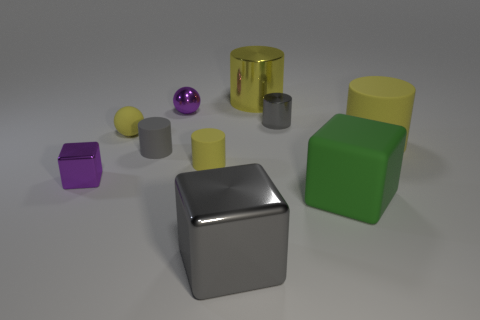If I were teaching a child about shapes, how could I use this image? This image is an excellent resource for teaching shapes. You can point out the sphere, cube, and cylinder, and explain how a cube has six equal square faces, a sphere has a round, three-dimensional shape, and a cylinder has two circular bases and a curved side. You can also discuss the concept of dimensions using the three different shapes to illustrate the point. 